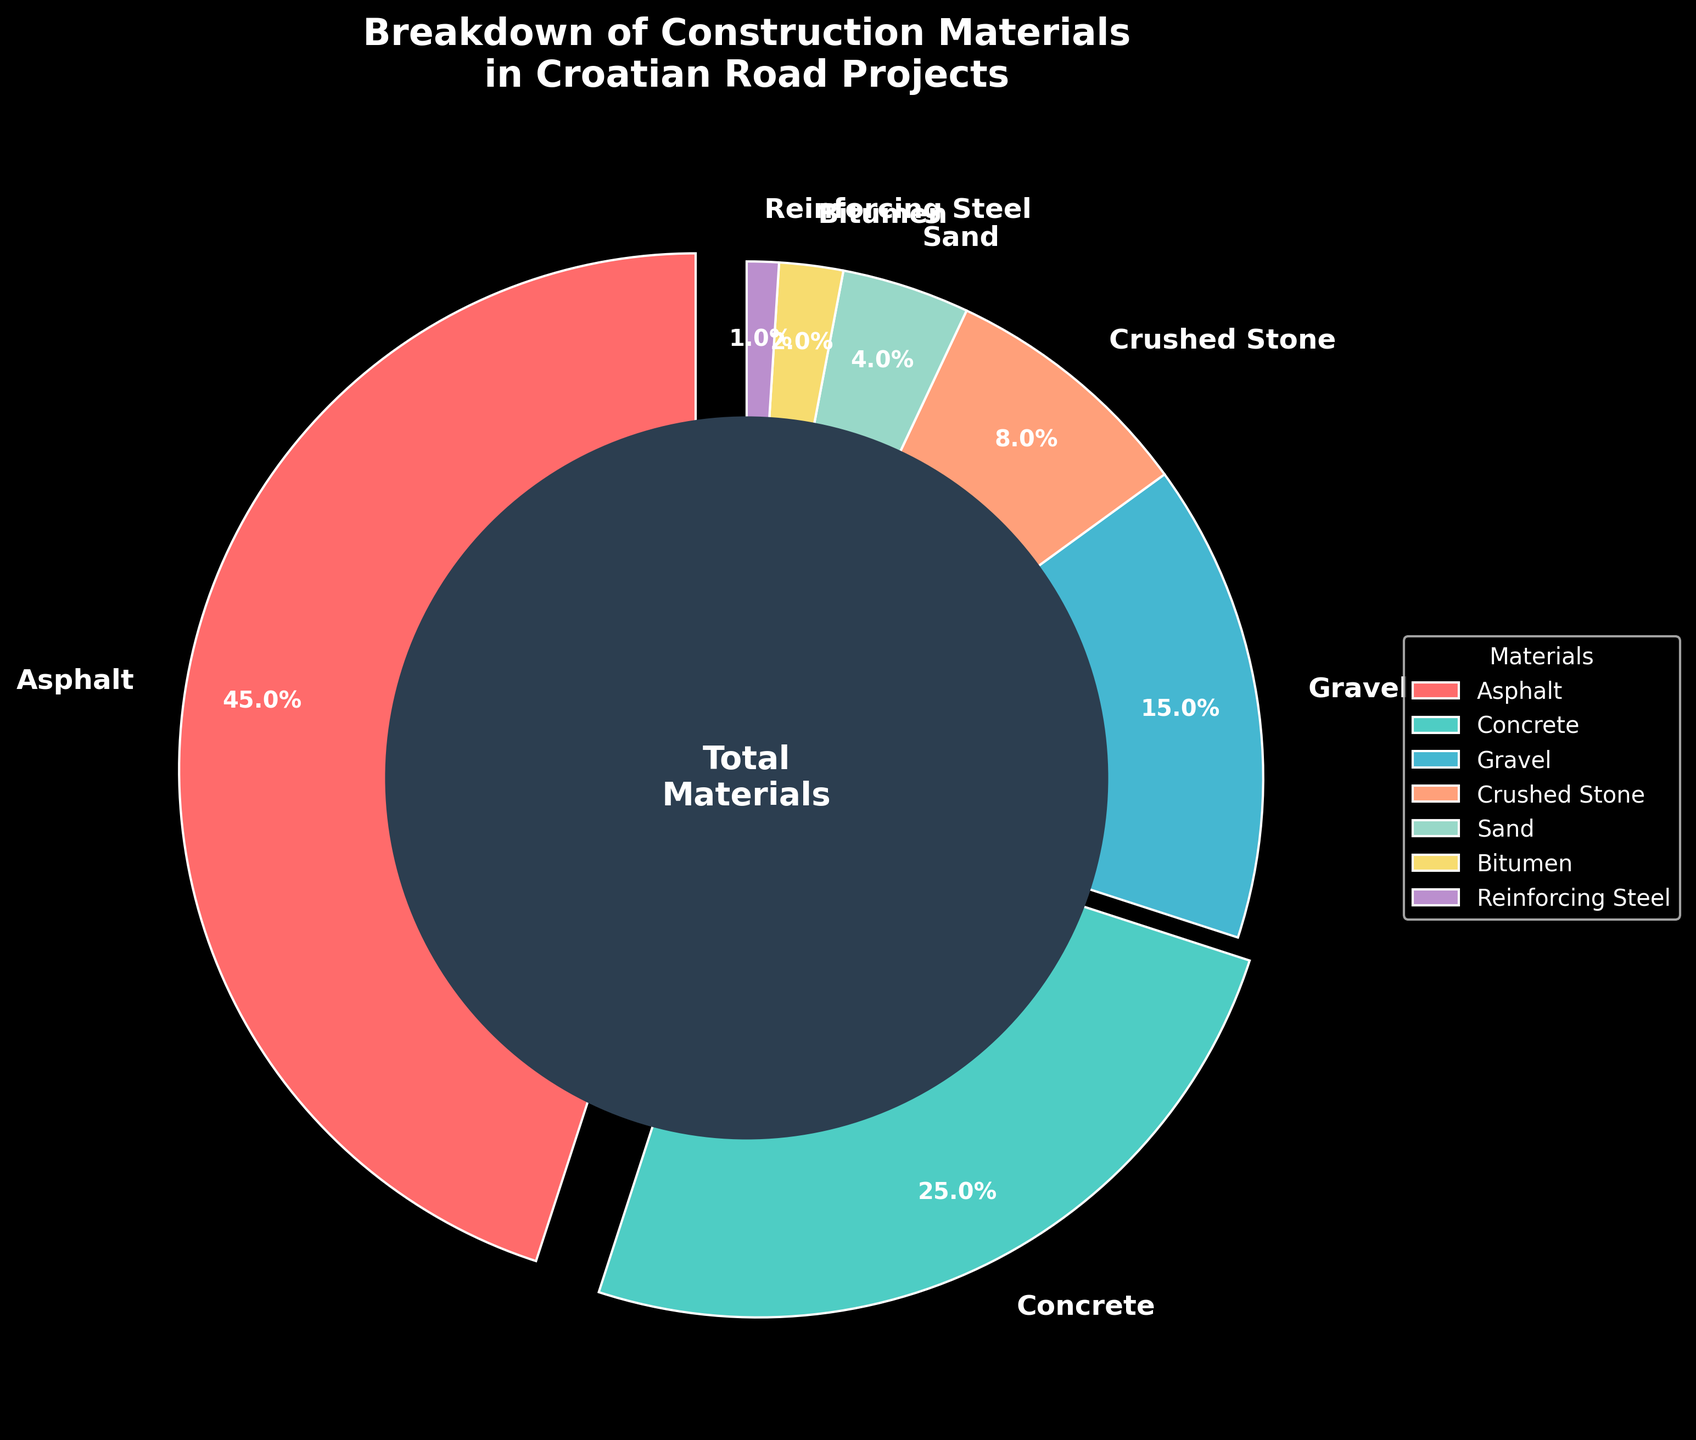Which material is used the most in Croatian road projects? Asphalt occupies the largest slice of the pie chart. It is labeled with a percentage of 45%, making it the most used material.
Answer: Asphalt Which material is used the least in Croatian road projects? The smallest slice of the pie chart corresponds to Reinforcing Steel, labeled with a percentage of 1%.
Answer: Reinforcing Steel What is the combined percentage of Gravel and Crushed Stone usage? The percentage of Gravel is 15% and Crushed Stone is 8%. Adding them together: 15% + 8% = 23%.
Answer: 23% Is the percentage of Bitumen usage greater than Sand usage? In the pie chart, Bitumen is labeled with 2% while Sand is labeled with 4%. Since 2% < 4%, Bitumen usage is not greater than Sand usage.
Answer: No How much more percentage is Concrete used compared to Gravel? Concrete has a usage of 25% while Gravel has 15%. The difference is: 25% - 15% = 10%.
Answer: 10% What materials have their slices exploded in the pie chart, and why might this have been done? The exploded slices are Asphalt and Concrete, indicating they are significant. Asphalt and Concrete account for a combined 70% usage, making them the predominant materials in Croatian road projects.
Answer: Asphalt and Concrete What is the total percentage of the 'other' materials excluding Asphalt, Concrete, and Gravel? Adding the percentages of Crushed Stone (8%), Sand (4%), Bitumen (2%), and Reinforcing Steel (1%): 8% + 4% + 2% + 1% = 15%.
Answer: 15% Which material segment appears in green, and what is its percentage usage? Concrete appears in green on the pie chart and has a percentage usage of 25%.
Answer: Concrete, 25% Is the combined percentage of Sand and Bitumen usage greater than the percentage of Crushed Stone usage? Sand usage is 4% and Bitumen usage is 2%. Adding them: 4% + 2% = 6%. Crushed Stone usage is 8%. Since 6% < 8%, the combined usage of Sand and Bitumen is not greater than Crushed Stone.
Answer: No What is the visual cue used to identify the most significant materials in the chart? Exploding the largest slices (Asphalt and Concrete) and using contrasting colors make them stand out visually. This highlights their significance in material usage.
Answer: Exploding slices and contrasting colors 